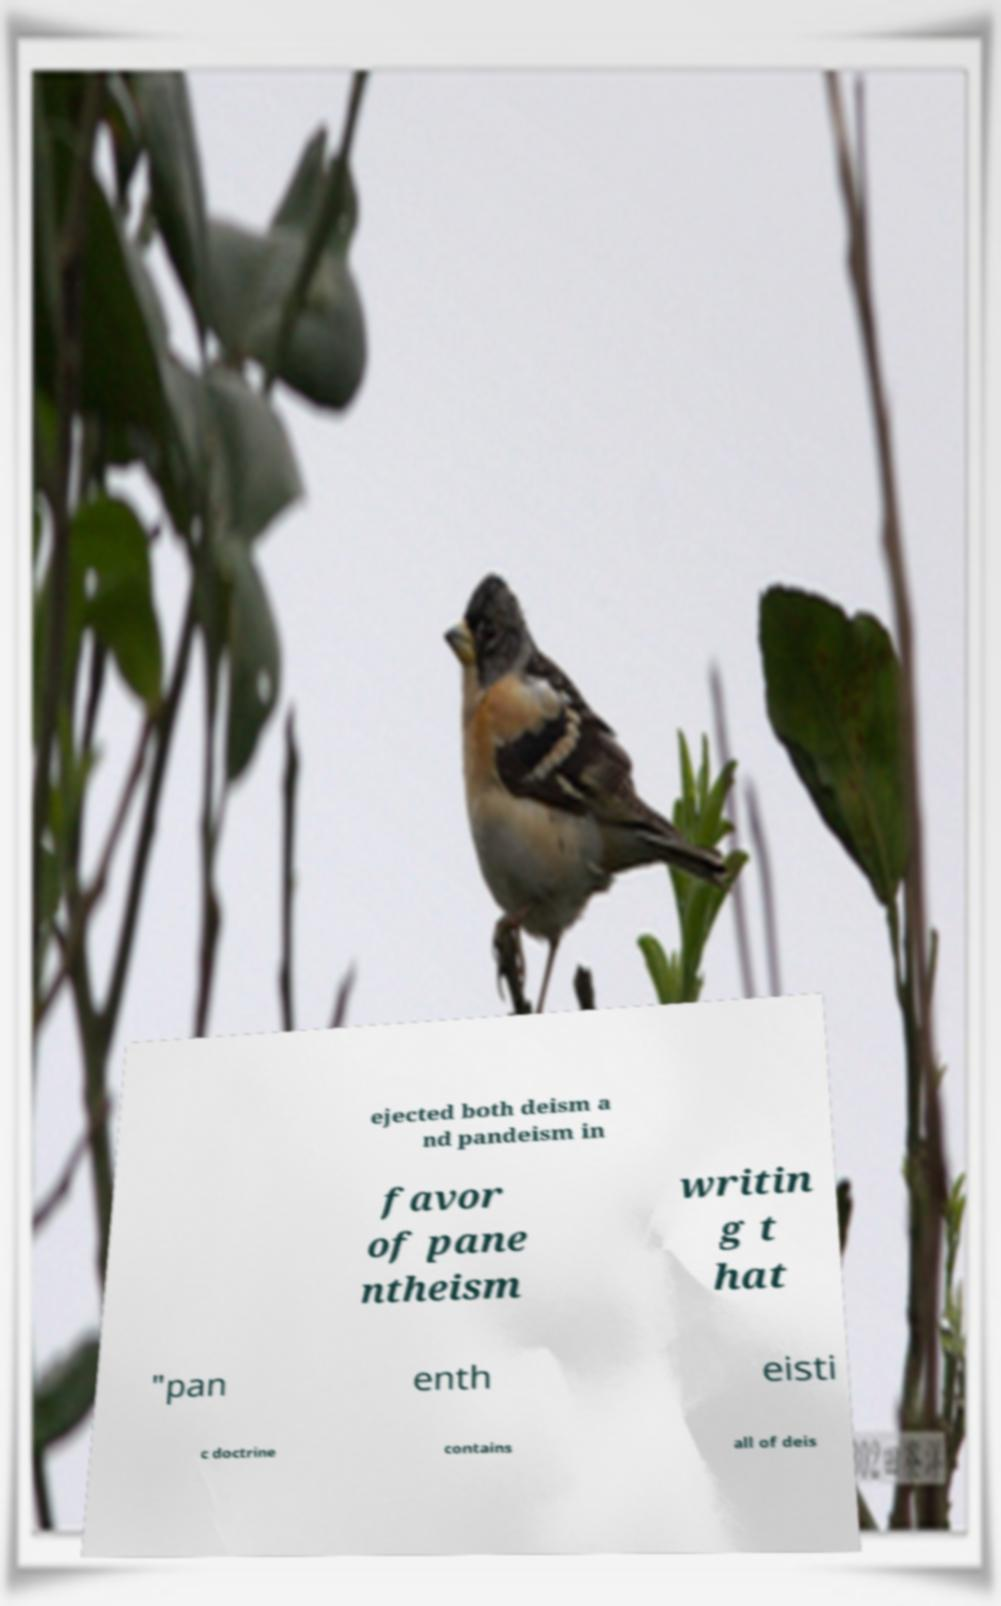I need the written content from this picture converted into text. Can you do that? ejected both deism a nd pandeism in favor of pane ntheism writin g t hat "pan enth eisti c doctrine contains all of deis 